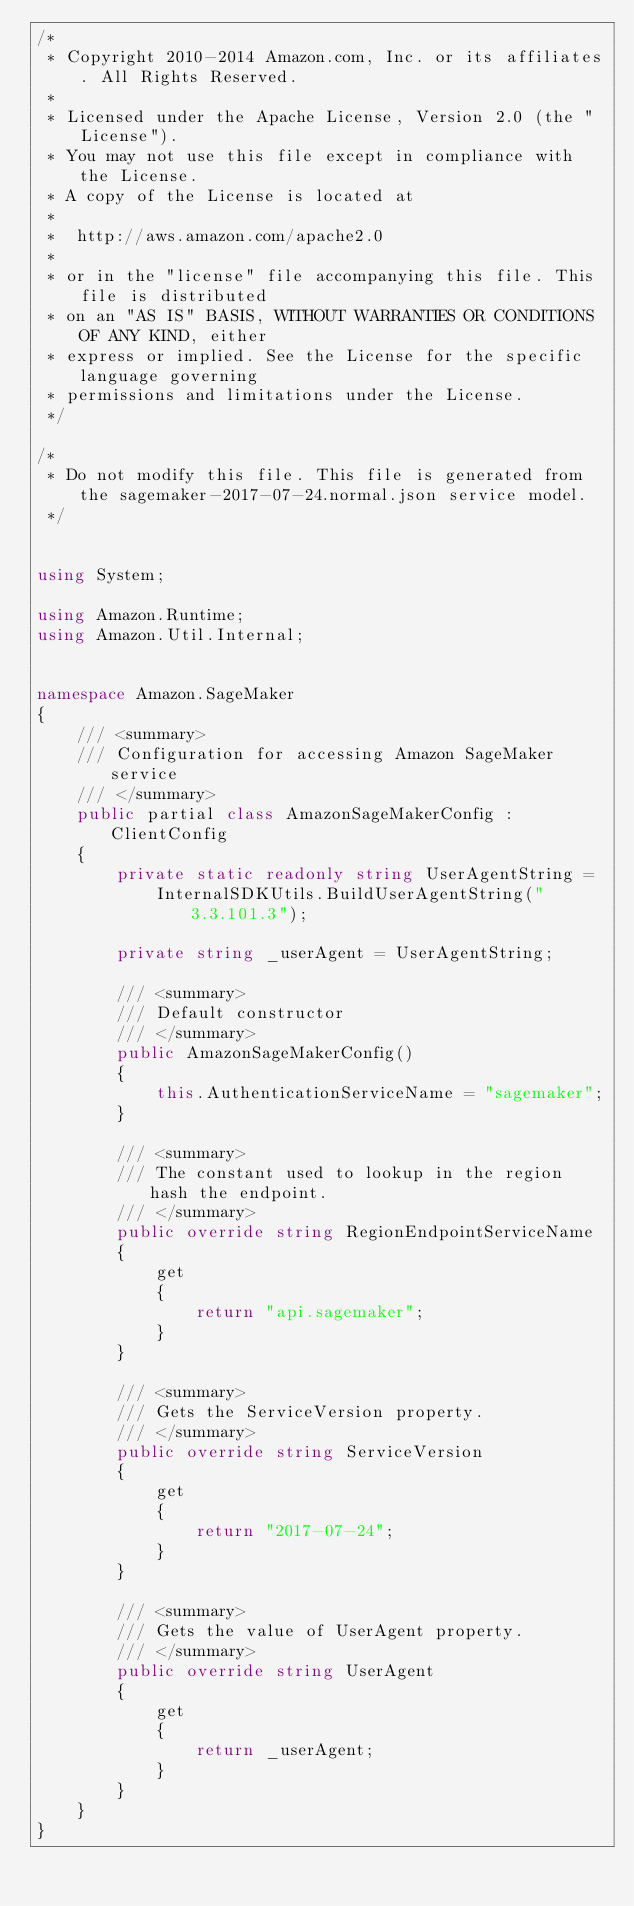<code> <loc_0><loc_0><loc_500><loc_500><_C#_>/*
 * Copyright 2010-2014 Amazon.com, Inc. or its affiliates. All Rights Reserved.
 * 
 * Licensed under the Apache License, Version 2.0 (the "License").
 * You may not use this file except in compliance with the License.
 * A copy of the License is located at
 * 
 *  http://aws.amazon.com/apache2.0
 * 
 * or in the "license" file accompanying this file. This file is distributed
 * on an "AS IS" BASIS, WITHOUT WARRANTIES OR CONDITIONS OF ANY KIND, either
 * express or implied. See the License for the specific language governing
 * permissions and limitations under the License.
 */

/*
 * Do not modify this file. This file is generated from the sagemaker-2017-07-24.normal.json service model.
 */


using System;

using Amazon.Runtime;
using Amazon.Util.Internal;


namespace Amazon.SageMaker
{
    /// <summary>
    /// Configuration for accessing Amazon SageMaker service
    /// </summary>
    public partial class AmazonSageMakerConfig : ClientConfig
    {
        private static readonly string UserAgentString =
            InternalSDKUtils.BuildUserAgentString("3.3.101.3");

        private string _userAgent = UserAgentString;

        /// <summary>
        /// Default constructor
        /// </summary>
        public AmazonSageMakerConfig()
        {
            this.AuthenticationServiceName = "sagemaker";
        }

        /// <summary>
        /// The constant used to lookup in the region hash the endpoint.
        /// </summary>
        public override string RegionEndpointServiceName
        {
            get
            {
                return "api.sagemaker";
            }
        }

        /// <summary>
        /// Gets the ServiceVersion property.
        /// </summary>
        public override string ServiceVersion
        {
            get
            {
                return "2017-07-24";
            }
        }

        /// <summary>
        /// Gets the value of UserAgent property.
        /// </summary>
        public override string UserAgent
        {
            get
            {
                return _userAgent;
            }
        }
    }
}</code> 